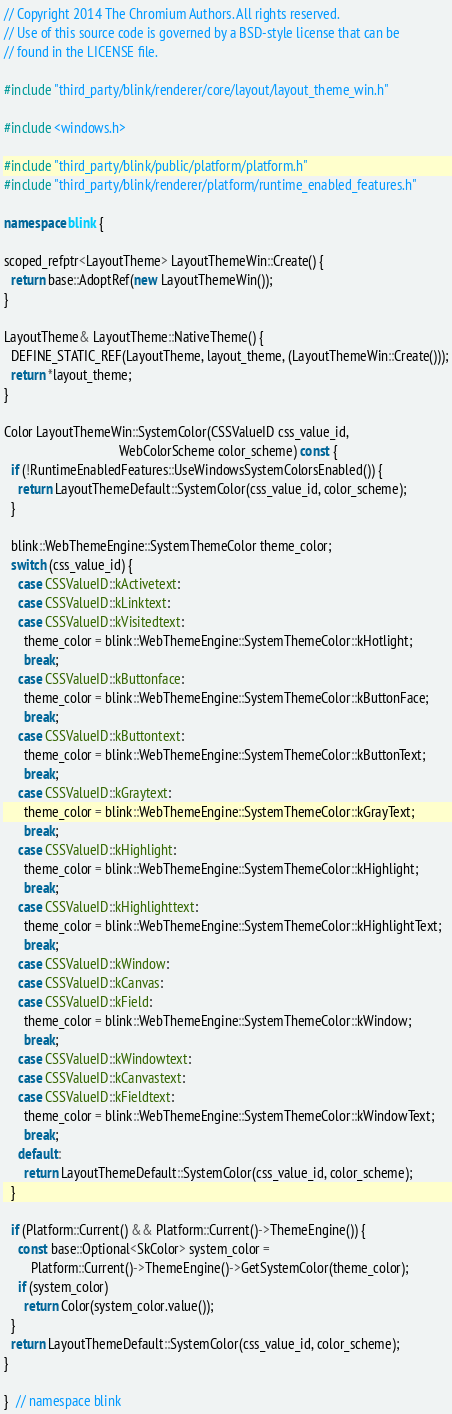Convert code to text. <code><loc_0><loc_0><loc_500><loc_500><_C++_>// Copyright 2014 The Chromium Authors. All rights reserved.
// Use of this source code is governed by a BSD-style license that can be
// found in the LICENSE file.

#include "third_party/blink/renderer/core/layout/layout_theme_win.h"

#include <windows.h>

#include "third_party/blink/public/platform/platform.h"
#include "third_party/blink/renderer/platform/runtime_enabled_features.h"

namespace blink {

scoped_refptr<LayoutTheme> LayoutThemeWin::Create() {
  return base::AdoptRef(new LayoutThemeWin());
}

LayoutTheme& LayoutTheme::NativeTheme() {
  DEFINE_STATIC_REF(LayoutTheme, layout_theme, (LayoutThemeWin::Create()));
  return *layout_theme;
}

Color LayoutThemeWin::SystemColor(CSSValueID css_value_id,
                                  WebColorScheme color_scheme) const {
  if (!RuntimeEnabledFeatures::UseWindowsSystemColorsEnabled()) {
    return LayoutThemeDefault::SystemColor(css_value_id, color_scheme);
  }

  blink::WebThemeEngine::SystemThemeColor theme_color;
  switch (css_value_id) {
    case CSSValueID::kActivetext:
    case CSSValueID::kLinktext:
    case CSSValueID::kVisitedtext:
      theme_color = blink::WebThemeEngine::SystemThemeColor::kHotlight;
      break;
    case CSSValueID::kButtonface:
      theme_color = blink::WebThemeEngine::SystemThemeColor::kButtonFace;
      break;
    case CSSValueID::kButtontext:
      theme_color = blink::WebThemeEngine::SystemThemeColor::kButtonText;
      break;
    case CSSValueID::kGraytext:
      theme_color = blink::WebThemeEngine::SystemThemeColor::kGrayText;
      break;
    case CSSValueID::kHighlight:
      theme_color = blink::WebThemeEngine::SystemThemeColor::kHighlight;
      break;
    case CSSValueID::kHighlighttext:
      theme_color = blink::WebThemeEngine::SystemThemeColor::kHighlightText;
      break;
    case CSSValueID::kWindow:
    case CSSValueID::kCanvas:
    case CSSValueID::kField:
      theme_color = blink::WebThemeEngine::SystemThemeColor::kWindow;
      break;
    case CSSValueID::kWindowtext:
    case CSSValueID::kCanvastext:
    case CSSValueID::kFieldtext:
      theme_color = blink::WebThemeEngine::SystemThemeColor::kWindowText;
      break;
    default:
      return LayoutThemeDefault::SystemColor(css_value_id, color_scheme);
  }

  if (Platform::Current() && Platform::Current()->ThemeEngine()) {
    const base::Optional<SkColor> system_color =
        Platform::Current()->ThemeEngine()->GetSystemColor(theme_color);
    if (system_color)
      return Color(system_color.value());
  }
  return LayoutThemeDefault::SystemColor(css_value_id, color_scheme);
}

}  // namespace blink
</code> 